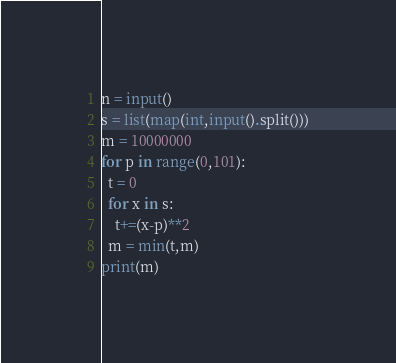<code> <loc_0><loc_0><loc_500><loc_500><_Python_>n = input()
s = list(map(int,input().split()))
m = 10000000
for p in range(0,101):
  t = 0
  for x in s:
    t+=(x-p)**2
  m = min(t,m)
print(m)</code> 